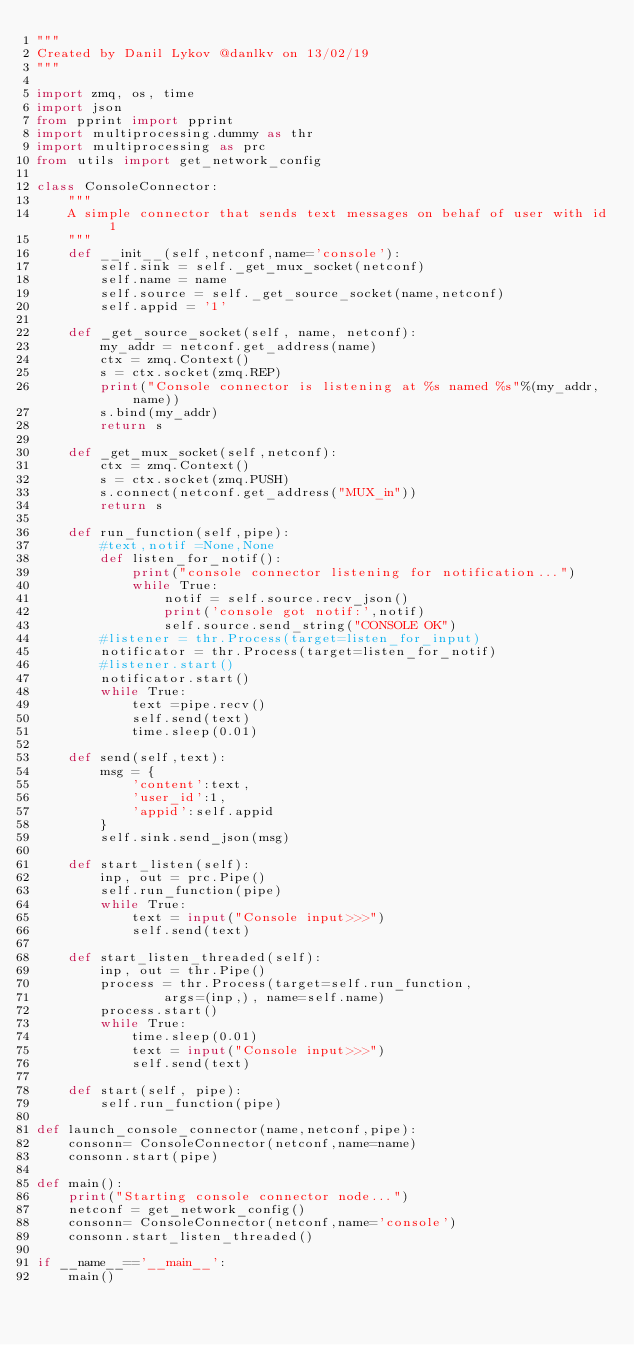<code> <loc_0><loc_0><loc_500><loc_500><_Python_>"""
Created by Danil Lykov @danlkv on 13/02/19
"""

import zmq, os, time
import json
from pprint import pprint
import multiprocessing.dummy as thr
import multiprocessing as prc
from utils import get_network_config

class ConsoleConnector:
    """
    A simple connector that sends text messages on behaf of user with id 1
    """
    def __init__(self,netconf,name='console'):
        self.sink = self._get_mux_socket(netconf)
        self.name = name
        self.source = self._get_source_socket(name,netconf)
        self.appid = '1'

    def _get_source_socket(self, name, netconf):
        my_addr = netconf.get_address(name)
        ctx = zmq.Context()
        s = ctx.socket(zmq.REP)
        print("Console connector is listening at %s named %s"%(my_addr,name))
        s.bind(my_addr)
        return s

    def _get_mux_socket(self,netconf):
        ctx = zmq.Context()
        s = ctx.socket(zmq.PUSH)
        s.connect(netconf.get_address("MUX_in"))
        return s

    def run_function(self,pipe):
        #text,notif =None,None
        def listen_for_notif():
            print("console connector listening for notification...")
            while True:
                notif = self.source.recv_json()
                print('console got notif:',notif)
                self.source.send_string("CONSOLE OK")
        #listener = thr.Process(target=listen_for_input)
        notificator = thr.Process(target=listen_for_notif)
        #listener.start()
        notificator.start()
        while True:
            text =pipe.recv()
            self.send(text)
            time.sleep(0.01)

    def send(self,text):
        msg = {
            'content':text,
            'user_id':1,
            'appid':self.appid
        }
        self.sink.send_json(msg)

    def start_listen(self):
        inp, out = prc.Pipe()
        self.run_function(pipe)
        while True:
            text = input("Console input>>>")
            self.send(text)

    def start_listen_threaded(self):
        inp, out = thr.Pipe()
        process = thr.Process(target=self.run_function,
                args=(inp,), name=self.name)
        process.start()
        while True:
            time.sleep(0.01)
            text = input("Console input>>>")
            self.send(text)

    def start(self, pipe):
        self.run_function(pipe)

def launch_console_connector(name,netconf,pipe):
    consonn= ConsoleConnector(netconf,name=name)
    consonn.start(pipe)

def main():
    print("Starting console connector node...")
    netconf = get_network_config()
    consonn= ConsoleConnector(netconf,name='console')
    consonn.start_listen_threaded()

if __name__=='__main__':
    main()
</code> 